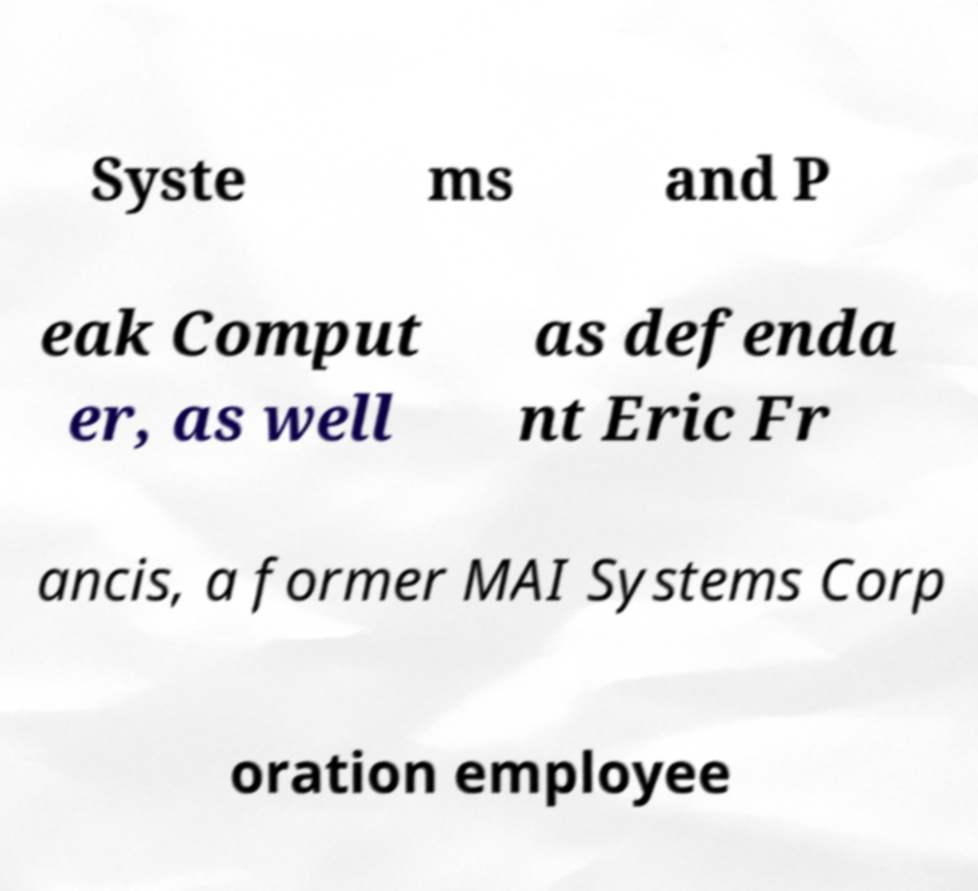Can you read and provide the text displayed in the image?This photo seems to have some interesting text. Can you extract and type it out for me? Syste ms and P eak Comput er, as well as defenda nt Eric Fr ancis, a former MAI Systems Corp oration employee 